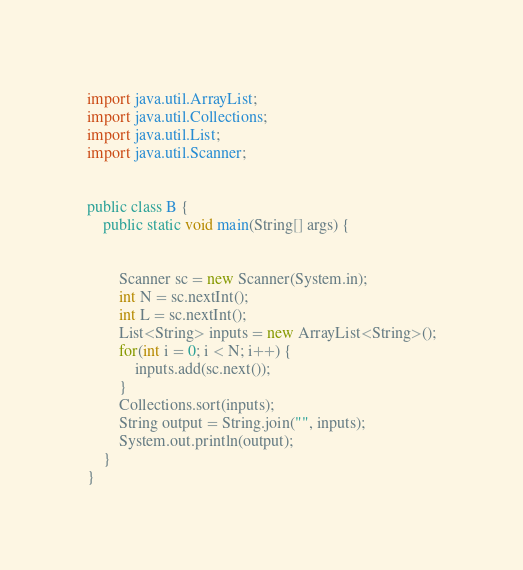<code> <loc_0><loc_0><loc_500><loc_500><_Java_>import java.util.ArrayList;
import java.util.Collections;
import java.util.List;
import java.util.Scanner;


public class B {
	public static void main(String[] args) {
		
		
		Scanner sc = new Scanner(System.in);
		int N = sc.nextInt();
		int L = sc.nextInt();
		List<String> inputs = new ArrayList<String>();
		for(int i = 0; i < N; i++) {
			inputs.add(sc.next());
		}
		Collections.sort(inputs);
		String output = String.join("", inputs);
		System.out.println(output);
	}
}</code> 